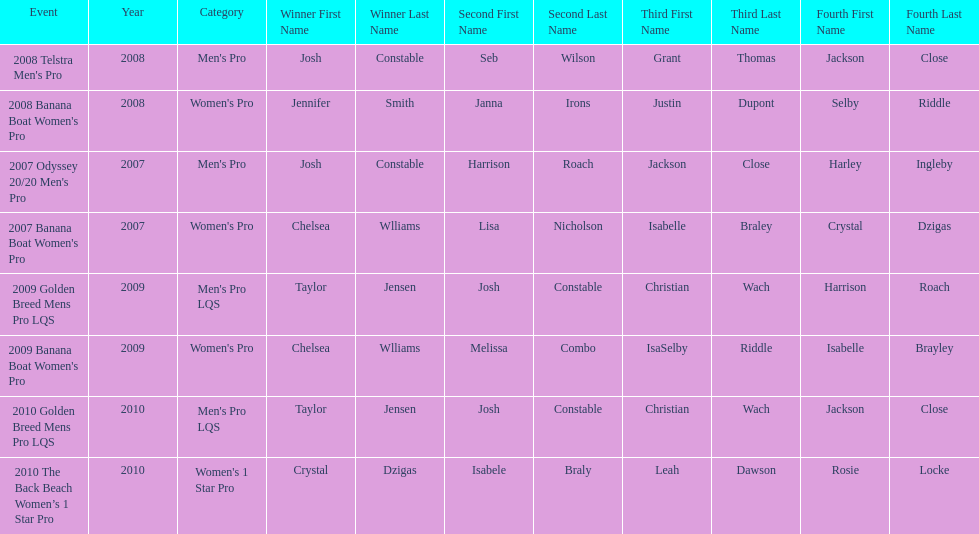In what two races did chelsea williams earn the same rank? 2007 Banana Boat Women's Pro, 2009 Banana Boat Women's Pro. 